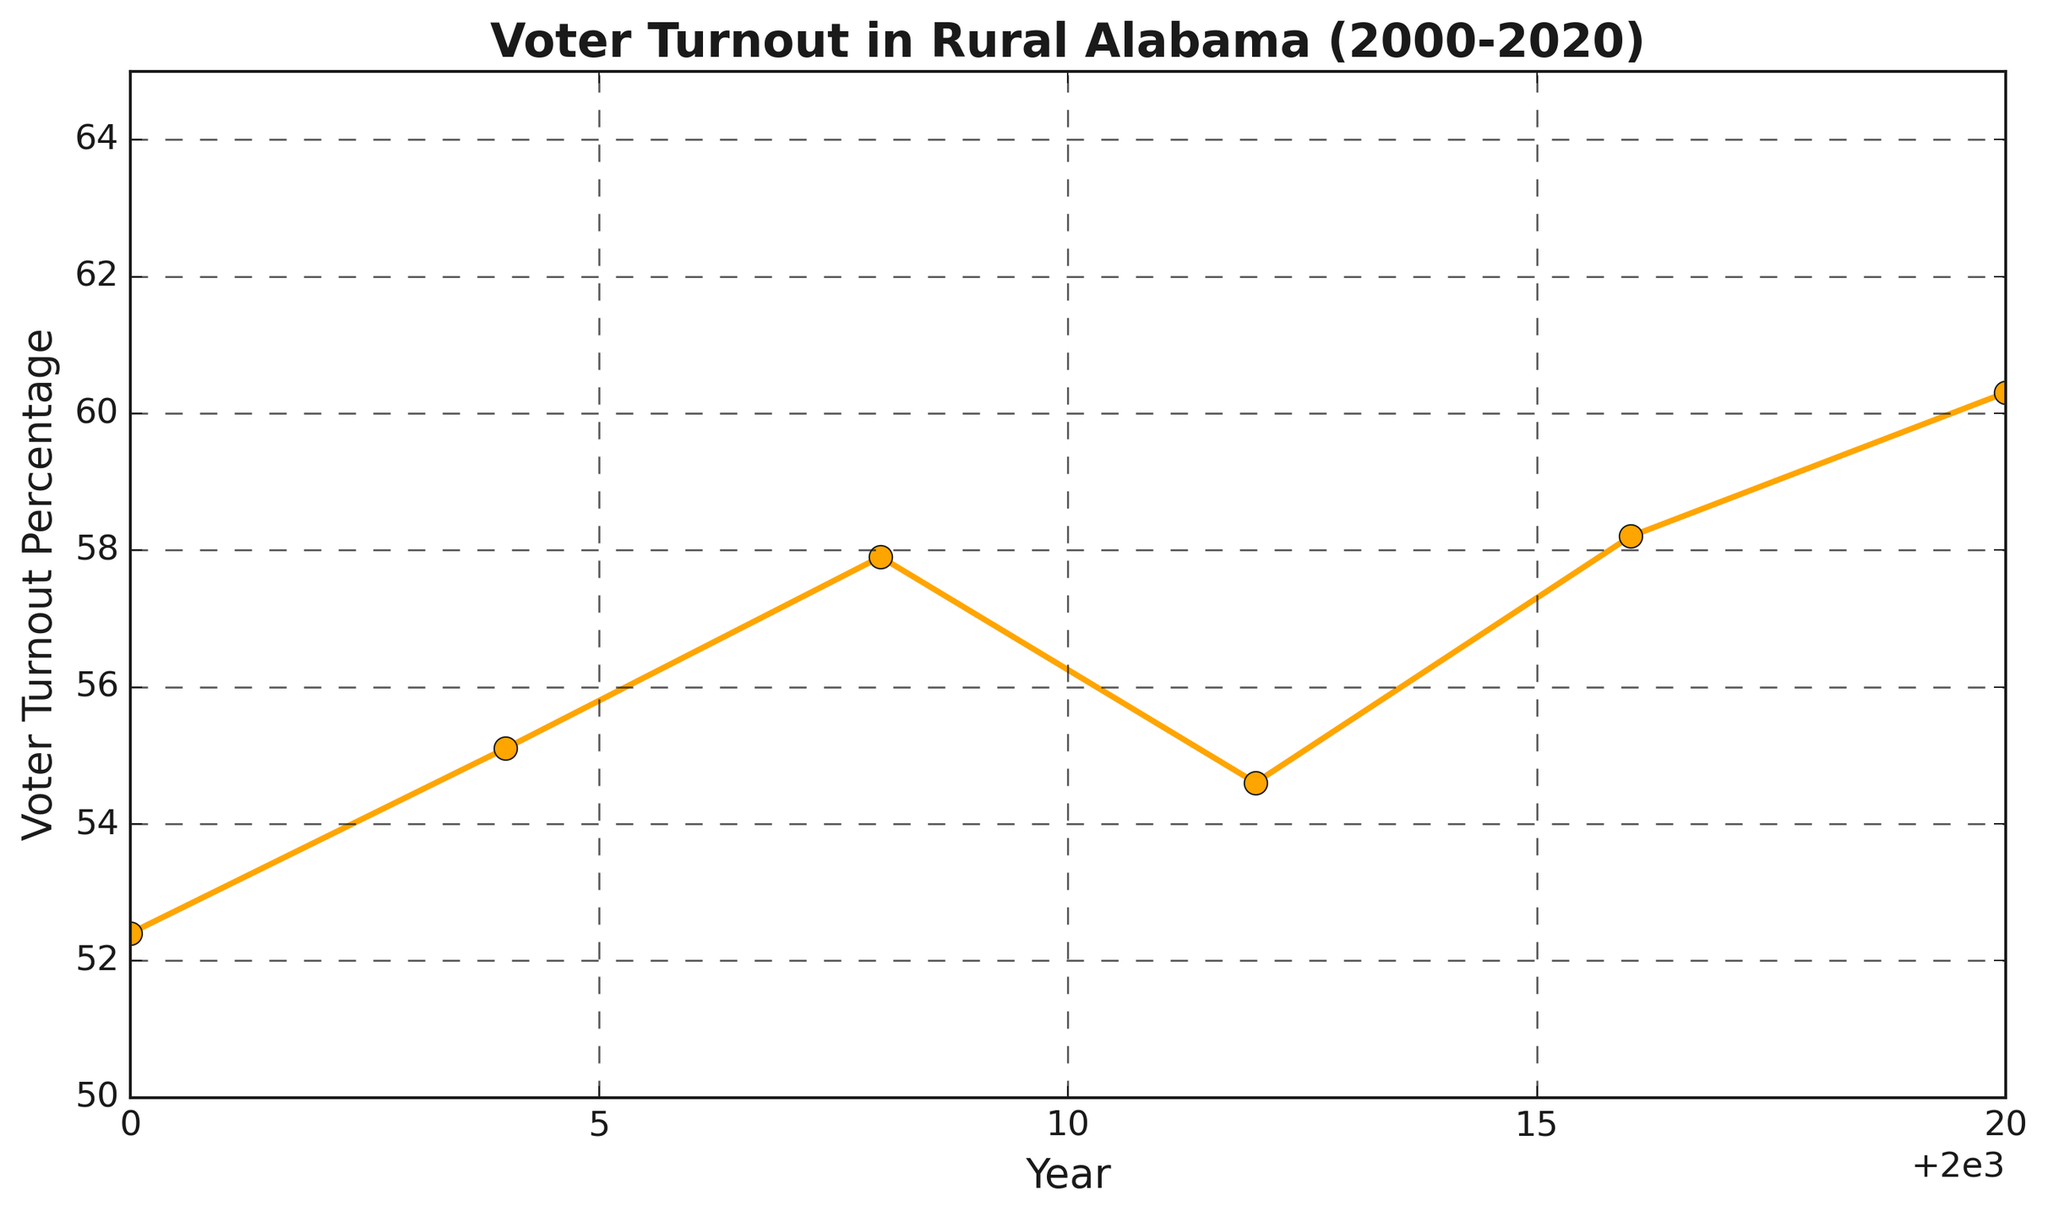What is the voter turnout percentage in 2004? Locate the year 2004 on the x-axis and trace vertically to the line. The corresponding y-value on the plot is the voter turnout percentage.
Answer: 55.1 How much did the voter turnout percentage increase from 2000 to 2020? Find the voter turnout percentages for 2000 (52.4) and 2020 (60.3), then subtract the former from the latter: 60.3 - 52.4.
Answer: 7.9 Which year saw the highest voter turnout? Observe the tallest marker or highest point on the line chart. This occurs in 2020.
Answer: 2020 Between which consecutive elections did the voter turnout percentage decrease the most? Check the slopes between each pair of consecutive years. The greatest negative slope appears between 2008 (57.9) and 2012 (54.6). Calculate the difference: 57.9 - 54.6.
Answer: 2008 to 2012 What is the average voter turnout percentage across all given years? Sum the voter turnout percentages: 52.4 + 55.1 + 57.9 + 54.6 + 58.2 + 60.3 = 338.5, then divide by the number of years: 338.5 / 6.
Answer: 56.4 How did voter turnout in 2016 compare to 2012? Compare the y-values for 2016 (58.2) and 2012 (54.6). Subtract 54.6 from 58.2.
Answer: 3.6 higher What is the trend in voter turnout percentage from 2000 to 2020? Observe the overall direction of the line; it generally increases from 2000 (52.4) to 2020 (60.3), showing an upward trend.
Answer: Upward trend What is the total change in voter turnout percentage from 2004 to 2008 and 2008 to 2012 combined? Calculate the change for each period then sum: (2008 - 2004) = 57.9 - 55.1 = 2.8, (2012 - 2008) = 54.6 - 57.9 = -3.3. Total: 2.8 - 3.3 = -0.5.
Answer: -0.5 What color is used for the line representing voter turnout? Identify the color used in the plot's line, which is orange.
Answer: Orange Which years had a voter turnout percentage above 55%? Check the y-values: 2008 (57.9), 2016 (58.2), and 2020 (60.3) are all above 55%.
Answer: 2008, 2016, 2020 